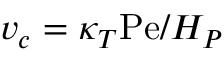<formula> <loc_0><loc_0><loc_500><loc_500>v _ { c } = \kappa _ { T } P e / H _ { P }</formula> 